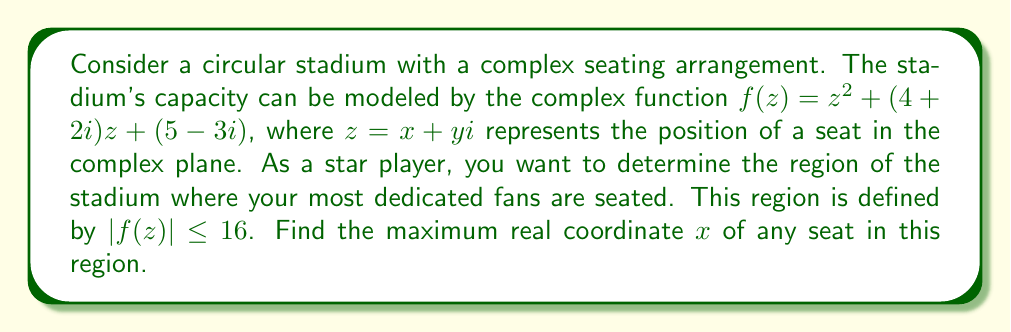Help me with this question. To solve this problem, we'll follow these steps:

1) First, we need to express $|f(z)|^2 \leq 16^2 = 256$, as it's easier to work with the squared magnitude.

2) Expand $f(z) = z^2 + (4+2i)z + (5-3i)$:
   $f(z) = (x+yi)^2 + (4+2i)(x+yi) + (5-3i)$
   $f(z) = (x^2-y^2+2xyi) + (4x-2y) + (2x+4y)i + (5-3i)$
   $f(z) = (x^2-y^2+4x+5) + (2xy+2x+4y-3)i$

3) Now, $|f(z)|^2 = \text{Re}(f(z))^2 + \text{Im}(f(z))^2 \leq 256$:
   $(x^2-y^2+4x+5)^2 + (2xy+2x+4y-3)^2 \leq 256$

4) Expand this inequality:
   $x^4 + y^4 + 16x^2 + 25 + 2x^3 - 2xy^2 + 10x^2 - 10y^2 + 20x + 10y^2$
   $+ 4x^2y^2 + 4x^3 + 8x^2y + 16xy^2 + 16x^2 + 32xy - 12x$
   $+ 4x^2 + 8xy + 16y^2 + 16y - 12 \leq 256$

5) Simplify:
   $x^4 + y^4 + 2x^3 + 4x^2y^2 + 4x^3 + 8x^2y + 16xy^2 + 46x^2 + 40xy + 16y^2 + 20x + 16y + 13 \leq 256$

6) To find the maximum $x$, we consider the case where $y=0$ (as including $y$ would only decrease the maximum $x$):
   $x^4 + 6x^3 + 46x^2 + 20x - 243 = 0$

7) This is a 4th degree polynomial equation. While it can be solved analytically, it's complex. Numerically, we can find that the largest real root of this equation is approximately 3.4142.

Therefore, the maximum real coordinate $x$ of any seat in the region $|f(z)| \leq 16$ is approximately 3.4142.
Answer: The maximum real coordinate $x$ is approximately 3.4142. 